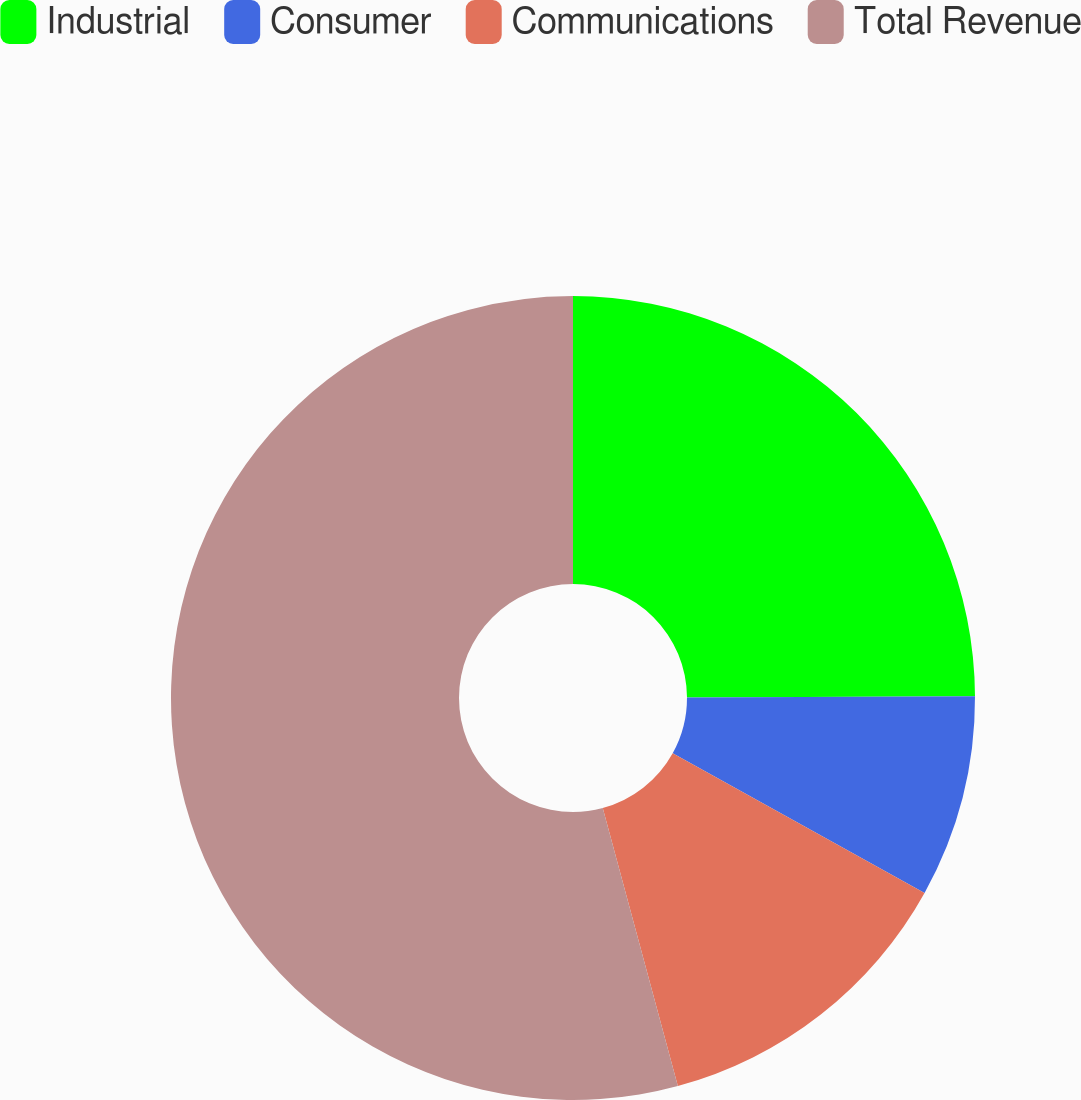Convert chart. <chart><loc_0><loc_0><loc_500><loc_500><pie_chart><fcel>Industrial<fcel>Consumer<fcel>Communications<fcel>Total Revenue<nl><fcel>24.93%<fcel>8.13%<fcel>12.74%<fcel>54.2%<nl></chart> 